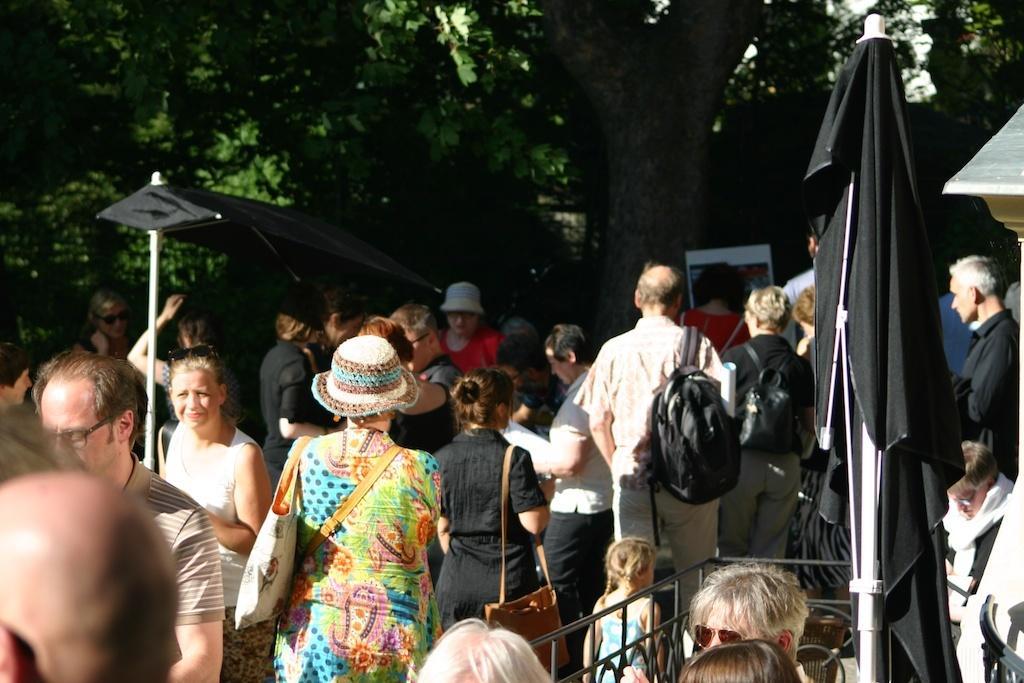Could you give a brief overview of what you see in this image? In this image there are persons standing and walking, there are tents and trees and there is a wall. 